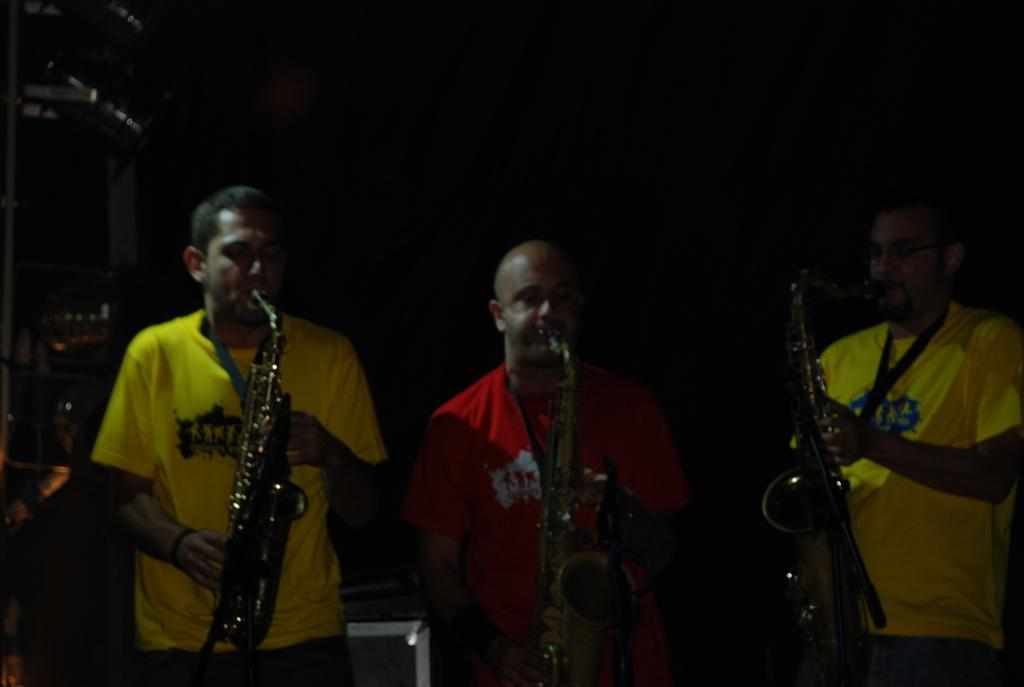What are the people in the image doing? The people in the image are standing and playing musical instruments. Can you describe the objects in the image? There is an object at the back of the image and another object on the left side of the image. How many people are in the group? The number of people in the group cannot be determined from the provided facts. What type of flowers can be seen in the image? There are no flowers present in the image. What season is depicted in the image? The provided facts do not mention any seasonal details, so it cannot be determined from the image. 